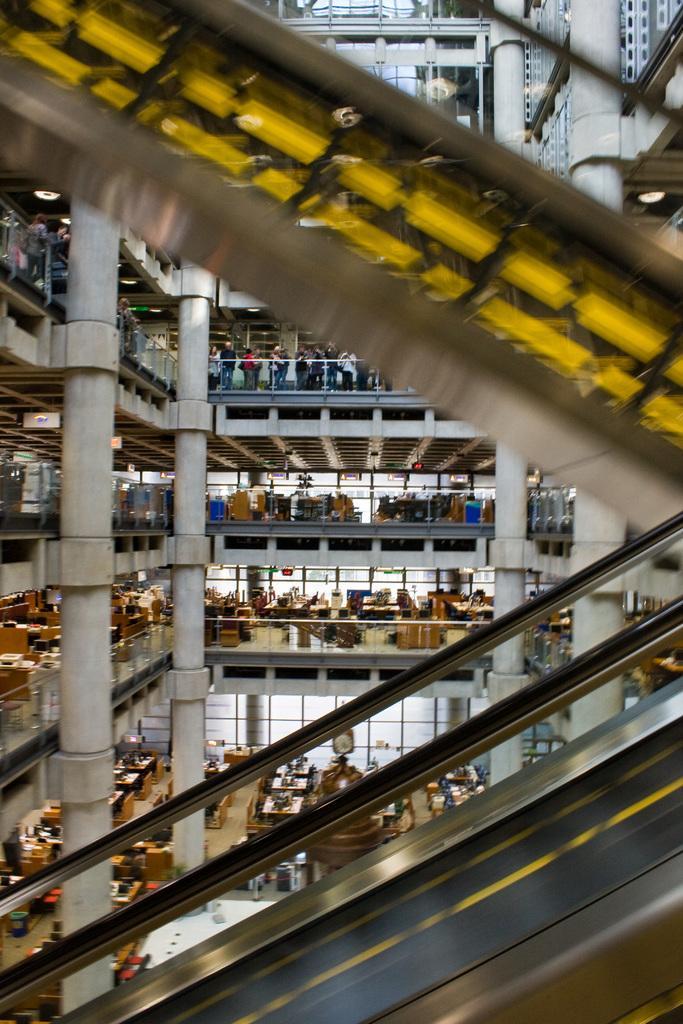Can you describe this image briefly? This is an inside of a building, where there are group of people, iron rods, tables, chairs, lights, escalators. 